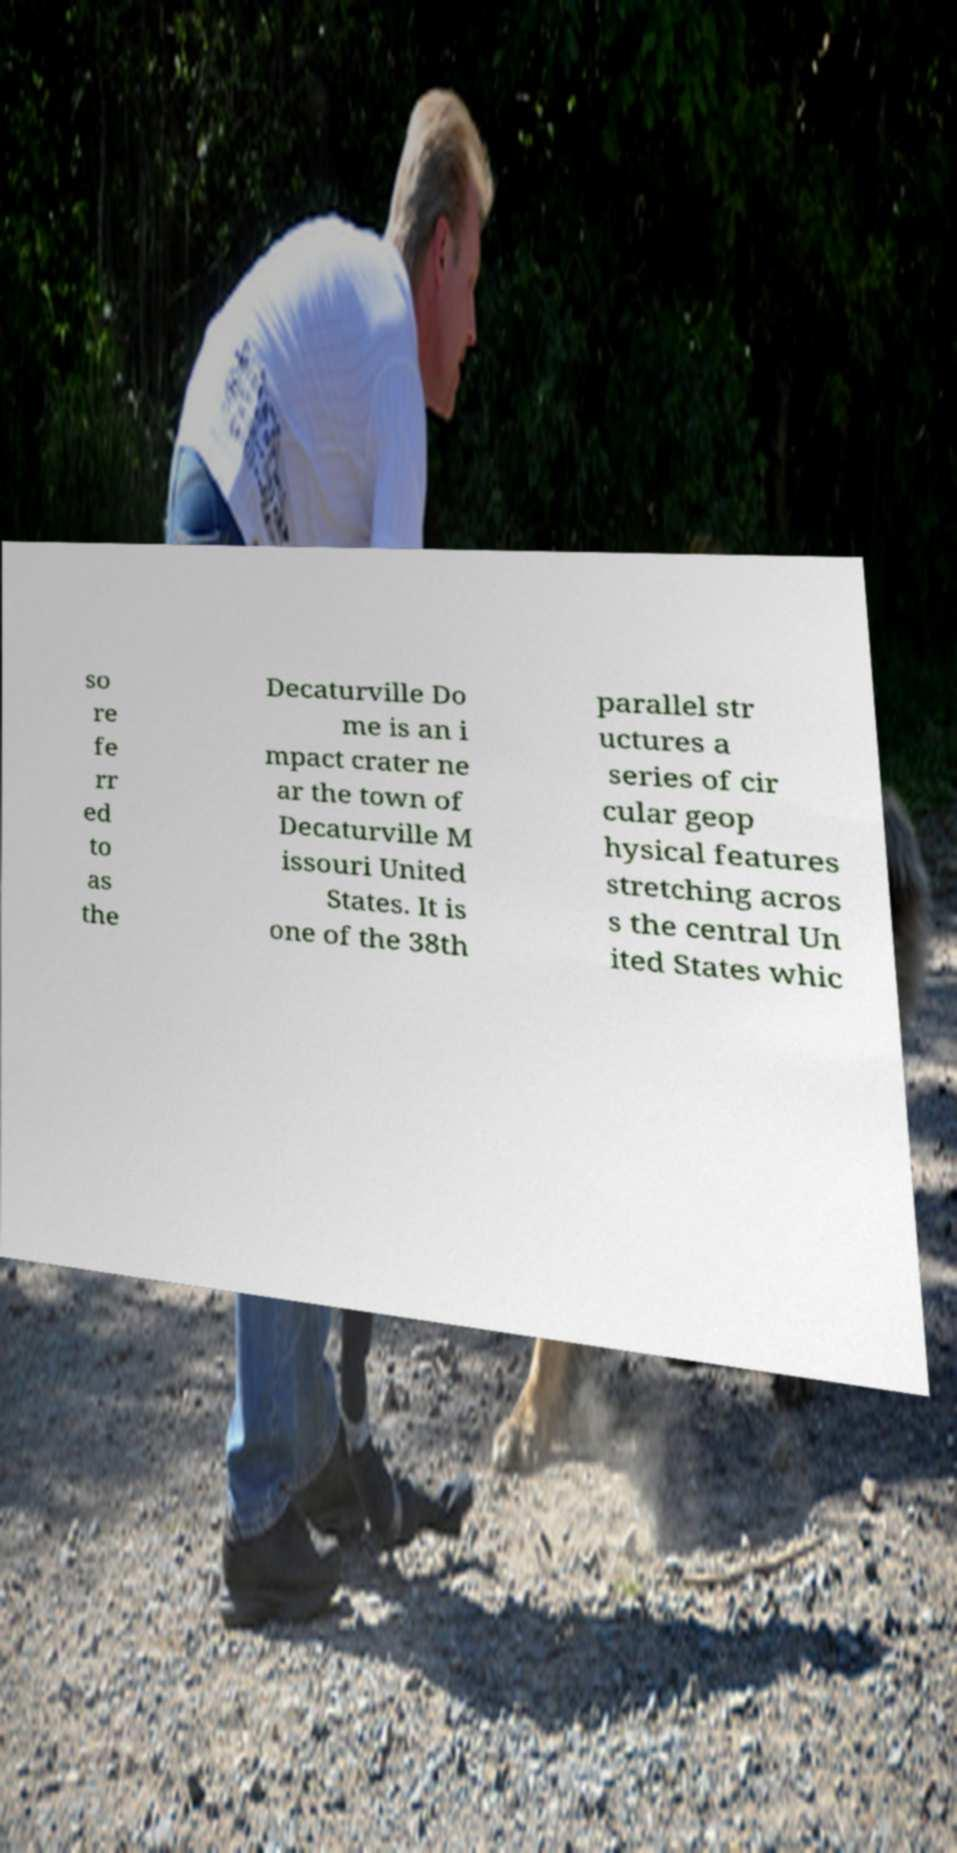Could you assist in decoding the text presented in this image and type it out clearly? so re fe rr ed to as the Decaturville Do me is an i mpact crater ne ar the town of Decaturville M issouri United States. It is one of the 38th parallel str uctures a series of cir cular geop hysical features stretching acros s the central Un ited States whic 